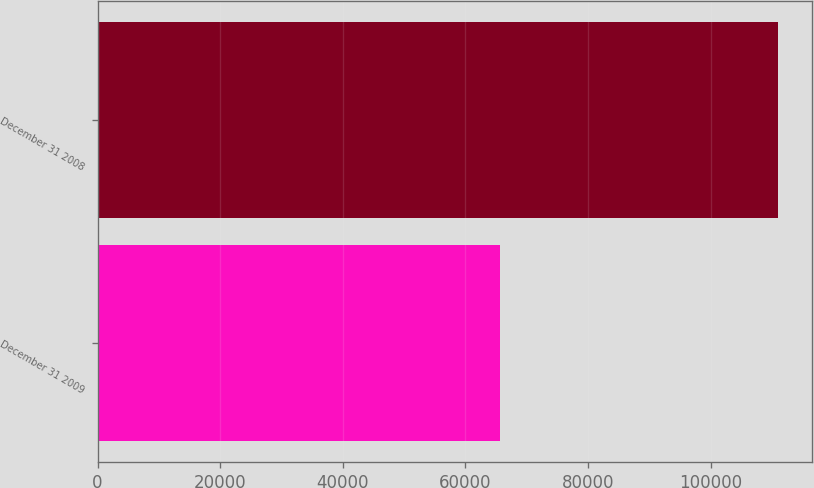Convert chart to OTSL. <chart><loc_0><loc_0><loc_500><loc_500><bar_chart><fcel>December 31 2009<fcel>December 31 2008<nl><fcel>65608<fcel>110919<nl></chart> 